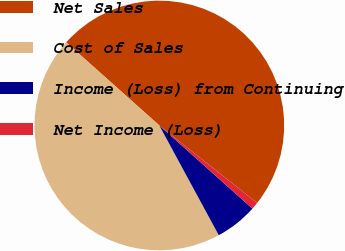<chart> <loc_0><loc_0><loc_500><loc_500><pie_chart><fcel>Net Sales<fcel>Cost of Sales<fcel>Income (Loss) from Continuing<fcel>Net Income (Loss)<nl><fcel>49.06%<fcel>44.5%<fcel>5.5%<fcel>0.94%<nl></chart> 